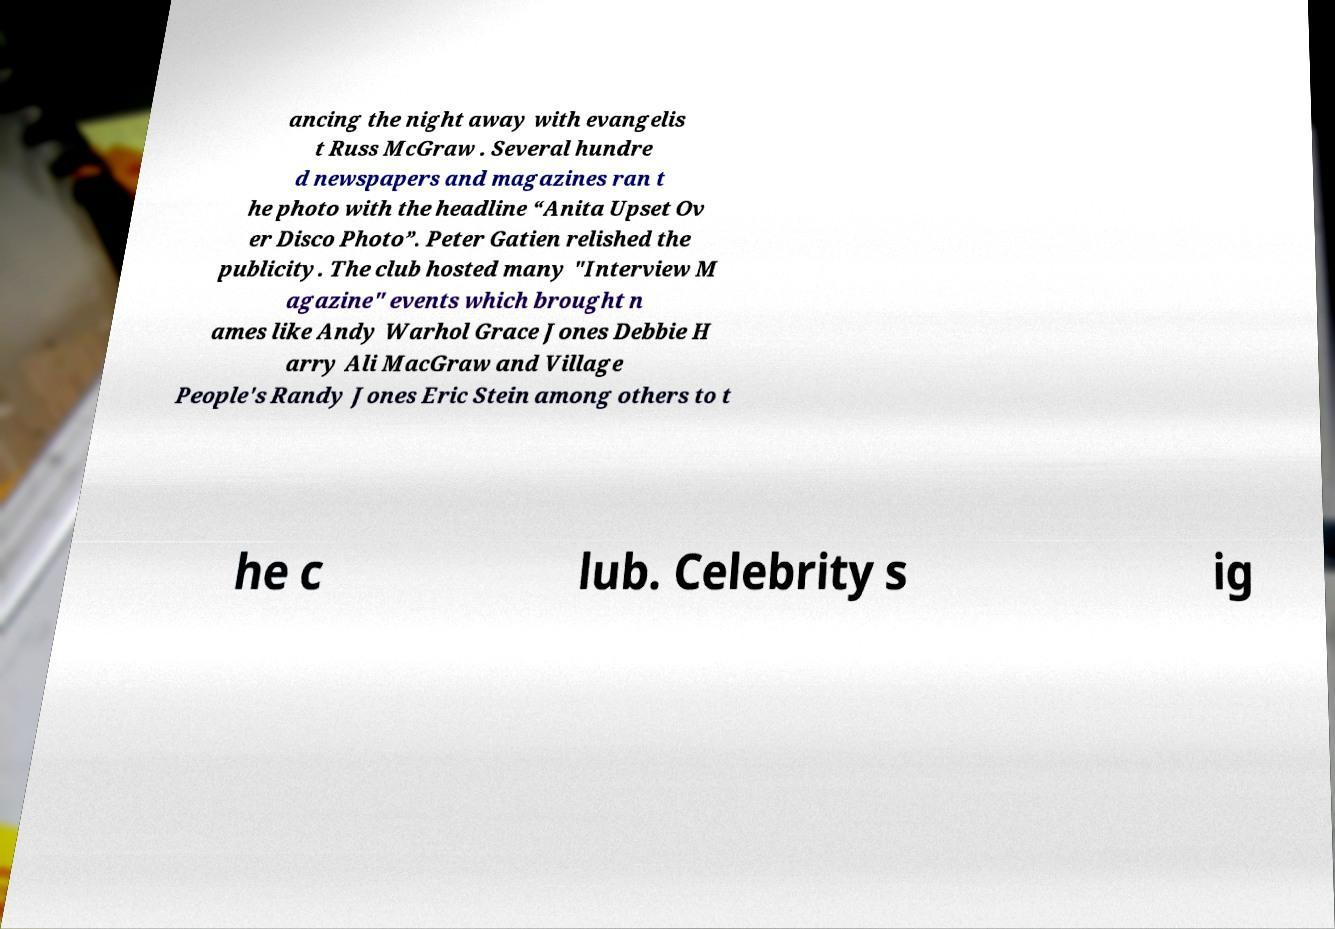Can you read and provide the text displayed in the image?This photo seems to have some interesting text. Can you extract and type it out for me? ancing the night away with evangelis t Russ McGraw . Several hundre d newspapers and magazines ran t he photo with the headline “Anita Upset Ov er Disco Photo”. Peter Gatien relished the publicity. The club hosted many "Interview M agazine" events which brought n ames like Andy Warhol Grace Jones Debbie H arry Ali MacGraw and Village People's Randy Jones Eric Stein among others to t he c lub. Celebrity s ig 